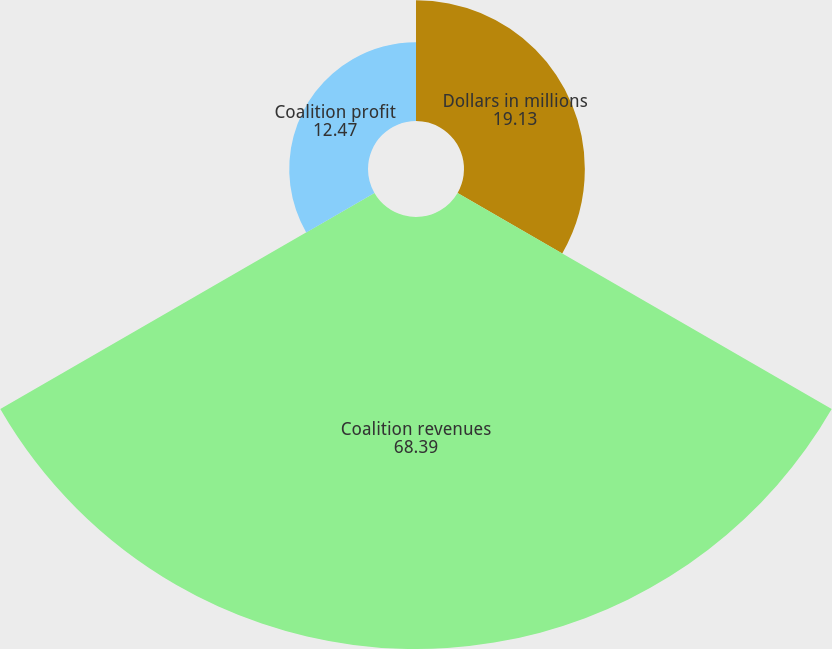Convert chart. <chart><loc_0><loc_0><loc_500><loc_500><pie_chart><fcel>Dollars in millions<fcel>Coalition revenues<fcel>Coalition profit<nl><fcel>19.13%<fcel>68.39%<fcel>12.47%<nl></chart> 